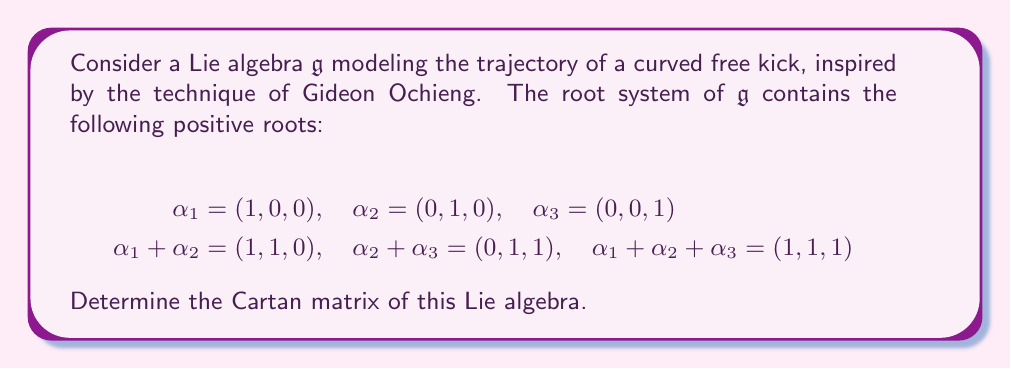What is the answer to this math problem? To solve this problem, let's follow these steps:

1) First, recall that the Cartan matrix $A = (a_{ij})$ for a Lie algebra with simple roots $\alpha_1, \alpha_2, ..., \alpha_n$ is defined by:

   $$a_{ij} = \frac{2(\alpha_i, \alpha_j)}{(\alpha_j, \alpha_j)}$$

   where $(\cdot,\cdot)$ denotes the inner product.

2) In this case, we have three simple roots: $\alpha_1, \alpha_2, \alpha_3$. So our Cartan matrix will be 3x3.

3) For the diagonal elements, we always have $a_{ii} = 2$.

4) For the off-diagonal elements, we need to check if the roots are connected in the Dynkin diagram. Roots are connected if their sum is also a root.

5) We can see that:
   - $\alpha_1 + \alpha_2$ is a root, so $\alpha_1$ and $\alpha_2$ are connected.
   - $\alpha_2 + \alpha_3$ is a root, so $\alpha_2$ and $\alpha_3$ are connected.
   - $\alpha_1 + \alpha_3$ is not a root, so $\alpha_1$ and $\alpha_3$ are not directly connected.

6) For connected simple roots, the corresponding matrix element is -1. For unconnected roots, it's 0.

7) Therefore, our Cartan matrix will look like this:

   $$A = \begin{pmatrix}
   2 & -1 & 0 \\
   -1 & 2 & -1 \\
   0 & -1 & 2
   \end{pmatrix}$$

This Cartan matrix corresponds to the Lie algebra of type $A_3$, which is isomorphic to $\mathfrak{sl}(4, \mathbb{C})$.
Answer: The Cartan matrix of the given Lie algebra is:

$$A = \begin{pmatrix}
2 & -1 & 0 \\
-1 & 2 & -1 \\
0 & -1 & 2
\end{pmatrix}$$ 